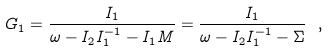<formula> <loc_0><loc_0><loc_500><loc_500>G _ { 1 } = \frac { I _ { 1 } } { \omega - I _ { 2 } I _ { 1 } ^ { - 1 } - I _ { 1 } M } = \frac { I _ { 1 } } { \omega - I _ { 2 } I _ { 1 } ^ { - 1 } - \Sigma } \ ,</formula> 